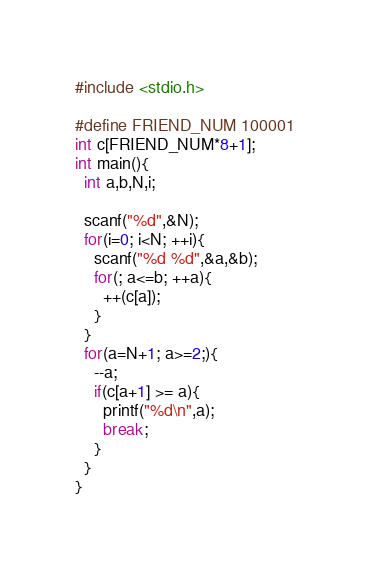Convert code to text. <code><loc_0><loc_0><loc_500><loc_500><_C_>#include <stdio.h>

#define FRIEND_NUM 100001
int c[FRIEND_NUM*8+1];
int main(){
  int a,b,N,i;

  scanf("%d",&N);
  for(i=0; i<N; ++i){
    scanf("%d %d",&a,&b);
    for(; a<=b; ++a){
      ++(c[a]);
    }
  }
  for(a=N+1; a>=2;){
    --a;
    if(c[a+1] >= a){
      printf("%d\n",a);
      break;
    }
  }
}</code> 